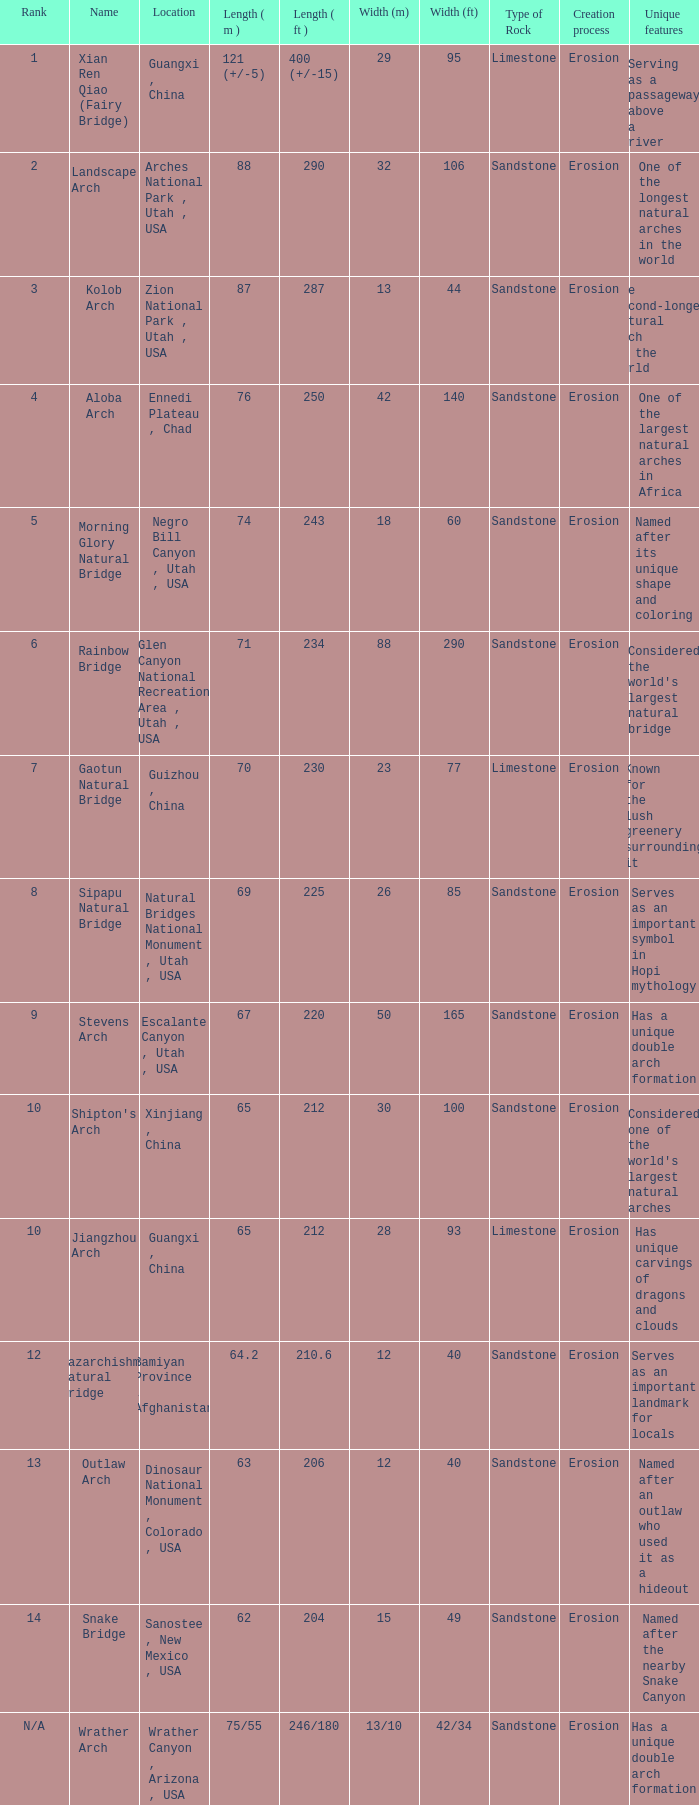What is the rank of the arch with a length in meters of 75/55? N/A. 